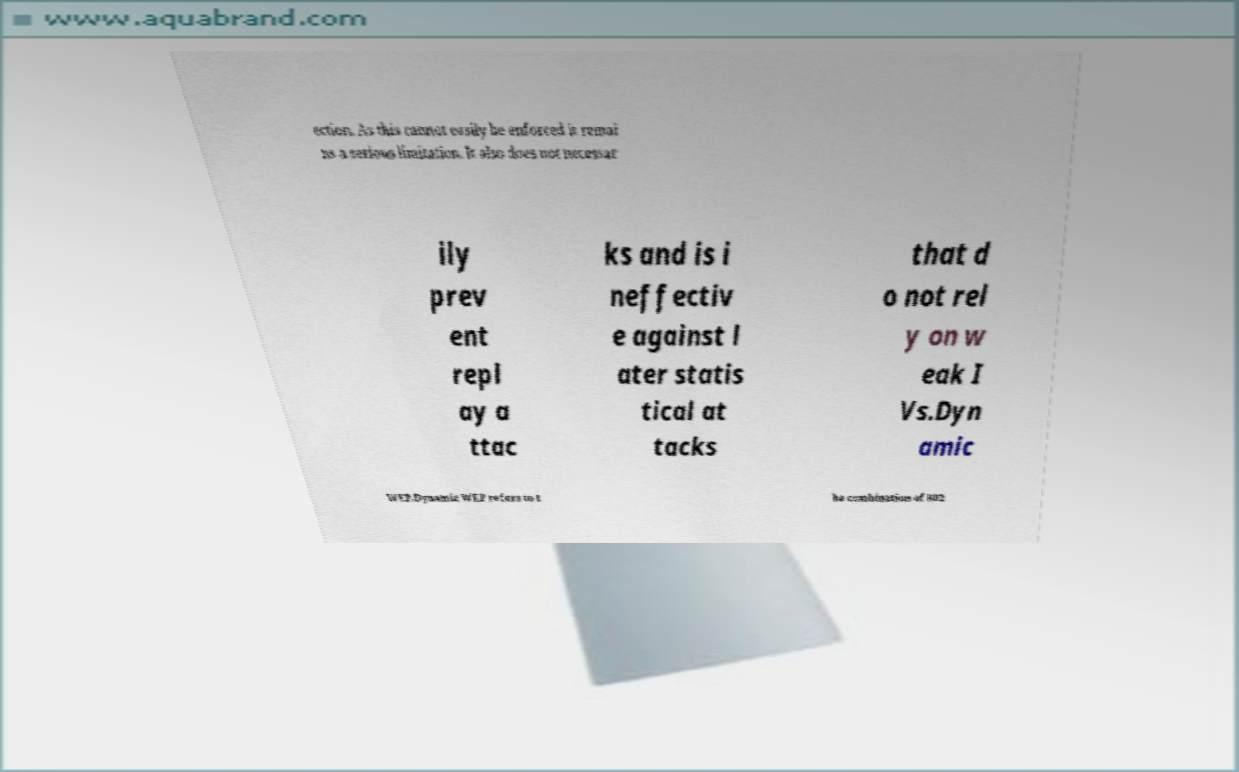What messages or text are displayed in this image? I need them in a readable, typed format. ection. As this cannot easily be enforced it remai ns a serious limitation. It also does not necessar ily prev ent repl ay a ttac ks and is i neffectiv e against l ater statis tical at tacks that d o not rel y on w eak I Vs.Dyn amic WEP.Dynamic WEP refers to t he combination of 802 